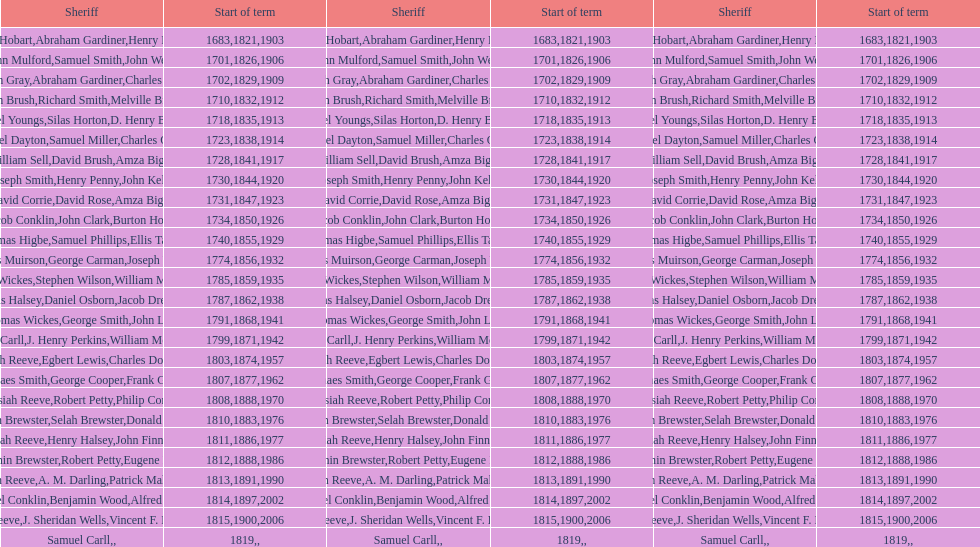Who was the sheriff in suffolk county before amza biggs first term there as sheriff? Charles O'Dell. 